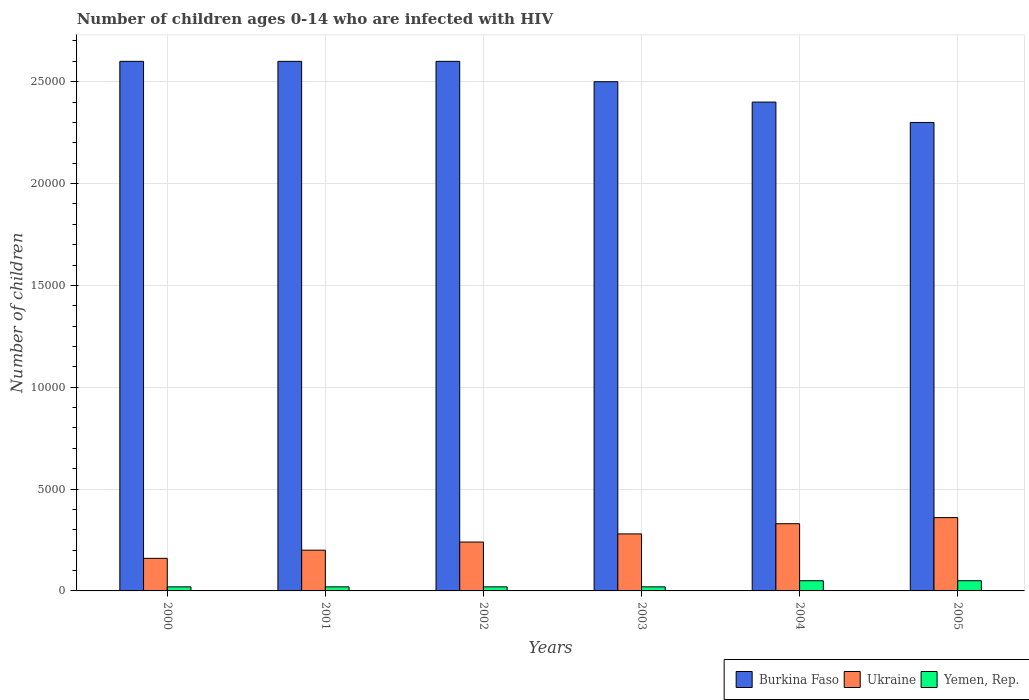How many different coloured bars are there?
Provide a succinct answer. 3. Are the number of bars per tick equal to the number of legend labels?
Provide a short and direct response. Yes. How many bars are there on the 3rd tick from the right?
Your answer should be very brief. 3. In how many cases, is the number of bars for a given year not equal to the number of legend labels?
Offer a very short reply. 0. What is the number of HIV infected children in Ukraine in 2002?
Your answer should be very brief. 2400. Across all years, what is the maximum number of HIV infected children in Yemen, Rep.?
Offer a very short reply. 500. Across all years, what is the minimum number of HIV infected children in Burkina Faso?
Give a very brief answer. 2.30e+04. In which year was the number of HIV infected children in Yemen, Rep. maximum?
Make the answer very short. 2004. In which year was the number of HIV infected children in Ukraine minimum?
Give a very brief answer. 2000. What is the total number of HIV infected children in Ukraine in the graph?
Provide a succinct answer. 1.57e+04. What is the difference between the number of HIV infected children in Yemen, Rep. in 2001 and the number of HIV infected children in Ukraine in 2004?
Give a very brief answer. -3100. What is the average number of HIV infected children in Ukraine per year?
Give a very brief answer. 2616.67. In the year 2002, what is the difference between the number of HIV infected children in Ukraine and number of HIV infected children in Burkina Faso?
Your answer should be very brief. -2.36e+04. What is the ratio of the number of HIV infected children in Ukraine in 2000 to that in 2005?
Make the answer very short. 0.44. What is the difference between the highest and the second highest number of HIV infected children in Yemen, Rep.?
Keep it short and to the point. 0. What is the difference between the highest and the lowest number of HIV infected children in Ukraine?
Ensure brevity in your answer.  2000. Is the sum of the number of HIV infected children in Yemen, Rep. in 2000 and 2004 greater than the maximum number of HIV infected children in Burkina Faso across all years?
Make the answer very short. No. What does the 2nd bar from the left in 2004 represents?
Offer a terse response. Ukraine. What does the 3rd bar from the right in 2000 represents?
Offer a terse response. Burkina Faso. How many bars are there?
Offer a very short reply. 18. How many years are there in the graph?
Provide a short and direct response. 6. Does the graph contain any zero values?
Provide a succinct answer. No. Does the graph contain grids?
Provide a succinct answer. Yes. Where does the legend appear in the graph?
Provide a succinct answer. Bottom right. What is the title of the graph?
Your answer should be very brief. Number of children ages 0-14 who are infected with HIV. Does "Caribbean small states" appear as one of the legend labels in the graph?
Offer a very short reply. No. What is the label or title of the X-axis?
Make the answer very short. Years. What is the label or title of the Y-axis?
Give a very brief answer. Number of children. What is the Number of children of Burkina Faso in 2000?
Your answer should be compact. 2.60e+04. What is the Number of children of Ukraine in 2000?
Give a very brief answer. 1600. What is the Number of children in Yemen, Rep. in 2000?
Provide a short and direct response. 200. What is the Number of children in Burkina Faso in 2001?
Give a very brief answer. 2.60e+04. What is the Number of children in Yemen, Rep. in 2001?
Your response must be concise. 200. What is the Number of children of Burkina Faso in 2002?
Make the answer very short. 2.60e+04. What is the Number of children in Ukraine in 2002?
Provide a succinct answer. 2400. What is the Number of children of Burkina Faso in 2003?
Ensure brevity in your answer.  2.50e+04. What is the Number of children of Ukraine in 2003?
Make the answer very short. 2800. What is the Number of children of Burkina Faso in 2004?
Provide a short and direct response. 2.40e+04. What is the Number of children of Ukraine in 2004?
Make the answer very short. 3300. What is the Number of children in Burkina Faso in 2005?
Your answer should be very brief. 2.30e+04. What is the Number of children of Ukraine in 2005?
Your answer should be compact. 3600. Across all years, what is the maximum Number of children of Burkina Faso?
Keep it short and to the point. 2.60e+04. Across all years, what is the maximum Number of children in Ukraine?
Give a very brief answer. 3600. Across all years, what is the maximum Number of children of Yemen, Rep.?
Make the answer very short. 500. Across all years, what is the minimum Number of children of Burkina Faso?
Your answer should be compact. 2.30e+04. Across all years, what is the minimum Number of children of Ukraine?
Your answer should be compact. 1600. Across all years, what is the minimum Number of children of Yemen, Rep.?
Provide a short and direct response. 200. What is the total Number of children in Burkina Faso in the graph?
Make the answer very short. 1.50e+05. What is the total Number of children of Ukraine in the graph?
Provide a short and direct response. 1.57e+04. What is the total Number of children of Yemen, Rep. in the graph?
Your answer should be very brief. 1800. What is the difference between the Number of children in Burkina Faso in 2000 and that in 2001?
Your response must be concise. 0. What is the difference between the Number of children of Ukraine in 2000 and that in 2001?
Provide a succinct answer. -400. What is the difference between the Number of children of Yemen, Rep. in 2000 and that in 2001?
Offer a terse response. 0. What is the difference between the Number of children in Ukraine in 2000 and that in 2002?
Provide a succinct answer. -800. What is the difference between the Number of children of Burkina Faso in 2000 and that in 2003?
Ensure brevity in your answer.  1000. What is the difference between the Number of children of Ukraine in 2000 and that in 2003?
Provide a short and direct response. -1200. What is the difference between the Number of children of Yemen, Rep. in 2000 and that in 2003?
Keep it short and to the point. 0. What is the difference between the Number of children in Burkina Faso in 2000 and that in 2004?
Ensure brevity in your answer.  2000. What is the difference between the Number of children in Ukraine in 2000 and that in 2004?
Ensure brevity in your answer.  -1700. What is the difference between the Number of children of Yemen, Rep. in 2000 and that in 2004?
Offer a terse response. -300. What is the difference between the Number of children in Burkina Faso in 2000 and that in 2005?
Make the answer very short. 3000. What is the difference between the Number of children in Ukraine in 2000 and that in 2005?
Keep it short and to the point. -2000. What is the difference between the Number of children of Yemen, Rep. in 2000 and that in 2005?
Offer a very short reply. -300. What is the difference between the Number of children in Ukraine in 2001 and that in 2002?
Offer a terse response. -400. What is the difference between the Number of children of Ukraine in 2001 and that in 2003?
Provide a short and direct response. -800. What is the difference between the Number of children of Yemen, Rep. in 2001 and that in 2003?
Offer a very short reply. 0. What is the difference between the Number of children in Ukraine in 2001 and that in 2004?
Keep it short and to the point. -1300. What is the difference between the Number of children of Yemen, Rep. in 2001 and that in 2004?
Your response must be concise. -300. What is the difference between the Number of children of Burkina Faso in 2001 and that in 2005?
Give a very brief answer. 3000. What is the difference between the Number of children of Ukraine in 2001 and that in 2005?
Your answer should be compact. -1600. What is the difference between the Number of children of Yemen, Rep. in 2001 and that in 2005?
Keep it short and to the point. -300. What is the difference between the Number of children of Ukraine in 2002 and that in 2003?
Provide a short and direct response. -400. What is the difference between the Number of children of Yemen, Rep. in 2002 and that in 2003?
Provide a succinct answer. 0. What is the difference between the Number of children in Ukraine in 2002 and that in 2004?
Ensure brevity in your answer.  -900. What is the difference between the Number of children in Yemen, Rep. in 2002 and that in 2004?
Your response must be concise. -300. What is the difference between the Number of children of Burkina Faso in 2002 and that in 2005?
Give a very brief answer. 3000. What is the difference between the Number of children in Ukraine in 2002 and that in 2005?
Keep it short and to the point. -1200. What is the difference between the Number of children in Yemen, Rep. in 2002 and that in 2005?
Ensure brevity in your answer.  -300. What is the difference between the Number of children in Burkina Faso in 2003 and that in 2004?
Provide a succinct answer. 1000. What is the difference between the Number of children in Ukraine in 2003 and that in 2004?
Provide a succinct answer. -500. What is the difference between the Number of children in Yemen, Rep. in 2003 and that in 2004?
Your answer should be compact. -300. What is the difference between the Number of children of Burkina Faso in 2003 and that in 2005?
Make the answer very short. 2000. What is the difference between the Number of children in Ukraine in 2003 and that in 2005?
Offer a very short reply. -800. What is the difference between the Number of children of Yemen, Rep. in 2003 and that in 2005?
Give a very brief answer. -300. What is the difference between the Number of children in Burkina Faso in 2004 and that in 2005?
Keep it short and to the point. 1000. What is the difference between the Number of children of Ukraine in 2004 and that in 2005?
Offer a very short reply. -300. What is the difference between the Number of children in Burkina Faso in 2000 and the Number of children in Ukraine in 2001?
Provide a succinct answer. 2.40e+04. What is the difference between the Number of children of Burkina Faso in 2000 and the Number of children of Yemen, Rep. in 2001?
Offer a very short reply. 2.58e+04. What is the difference between the Number of children of Ukraine in 2000 and the Number of children of Yemen, Rep. in 2001?
Your response must be concise. 1400. What is the difference between the Number of children of Burkina Faso in 2000 and the Number of children of Ukraine in 2002?
Give a very brief answer. 2.36e+04. What is the difference between the Number of children of Burkina Faso in 2000 and the Number of children of Yemen, Rep. in 2002?
Make the answer very short. 2.58e+04. What is the difference between the Number of children of Ukraine in 2000 and the Number of children of Yemen, Rep. in 2002?
Your response must be concise. 1400. What is the difference between the Number of children of Burkina Faso in 2000 and the Number of children of Ukraine in 2003?
Your answer should be very brief. 2.32e+04. What is the difference between the Number of children of Burkina Faso in 2000 and the Number of children of Yemen, Rep. in 2003?
Offer a terse response. 2.58e+04. What is the difference between the Number of children in Ukraine in 2000 and the Number of children in Yemen, Rep. in 2003?
Offer a very short reply. 1400. What is the difference between the Number of children in Burkina Faso in 2000 and the Number of children in Ukraine in 2004?
Provide a short and direct response. 2.27e+04. What is the difference between the Number of children of Burkina Faso in 2000 and the Number of children of Yemen, Rep. in 2004?
Offer a terse response. 2.55e+04. What is the difference between the Number of children in Ukraine in 2000 and the Number of children in Yemen, Rep. in 2004?
Offer a terse response. 1100. What is the difference between the Number of children of Burkina Faso in 2000 and the Number of children of Ukraine in 2005?
Offer a very short reply. 2.24e+04. What is the difference between the Number of children of Burkina Faso in 2000 and the Number of children of Yemen, Rep. in 2005?
Your response must be concise. 2.55e+04. What is the difference between the Number of children in Ukraine in 2000 and the Number of children in Yemen, Rep. in 2005?
Keep it short and to the point. 1100. What is the difference between the Number of children in Burkina Faso in 2001 and the Number of children in Ukraine in 2002?
Keep it short and to the point. 2.36e+04. What is the difference between the Number of children in Burkina Faso in 2001 and the Number of children in Yemen, Rep. in 2002?
Keep it short and to the point. 2.58e+04. What is the difference between the Number of children of Ukraine in 2001 and the Number of children of Yemen, Rep. in 2002?
Ensure brevity in your answer.  1800. What is the difference between the Number of children in Burkina Faso in 2001 and the Number of children in Ukraine in 2003?
Keep it short and to the point. 2.32e+04. What is the difference between the Number of children of Burkina Faso in 2001 and the Number of children of Yemen, Rep. in 2003?
Provide a succinct answer. 2.58e+04. What is the difference between the Number of children in Ukraine in 2001 and the Number of children in Yemen, Rep. in 2003?
Your response must be concise. 1800. What is the difference between the Number of children of Burkina Faso in 2001 and the Number of children of Ukraine in 2004?
Your answer should be very brief. 2.27e+04. What is the difference between the Number of children in Burkina Faso in 2001 and the Number of children in Yemen, Rep. in 2004?
Make the answer very short. 2.55e+04. What is the difference between the Number of children of Ukraine in 2001 and the Number of children of Yemen, Rep. in 2004?
Offer a very short reply. 1500. What is the difference between the Number of children of Burkina Faso in 2001 and the Number of children of Ukraine in 2005?
Keep it short and to the point. 2.24e+04. What is the difference between the Number of children in Burkina Faso in 2001 and the Number of children in Yemen, Rep. in 2005?
Provide a succinct answer. 2.55e+04. What is the difference between the Number of children in Ukraine in 2001 and the Number of children in Yemen, Rep. in 2005?
Make the answer very short. 1500. What is the difference between the Number of children in Burkina Faso in 2002 and the Number of children in Ukraine in 2003?
Your answer should be compact. 2.32e+04. What is the difference between the Number of children in Burkina Faso in 2002 and the Number of children in Yemen, Rep. in 2003?
Give a very brief answer. 2.58e+04. What is the difference between the Number of children in Ukraine in 2002 and the Number of children in Yemen, Rep. in 2003?
Provide a short and direct response. 2200. What is the difference between the Number of children in Burkina Faso in 2002 and the Number of children in Ukraine in 2004?
Provide a succinct answer. 2.27e+04. What is the difference between the Number of children in Burkina Faso in 2002 and the Number of children in Yemen, Rep. in 2004?
Ensure brevity in your answer.  2.55e+04. What is the difference between the Number of children in Ukraine in 2002 and the Number of children in Yemen, Rep. in 2004?
Your response must be concise. 1900. What is the difference between the Number of children in Burkina Faso in 2002 and the Number of children in Ukraine in 2005?
Provide a short and direct response. 2.24e+04. What is the difference between the Number of children in Burkina Faso in 2002 and the Number of children in Yemen, Rep. in 2005?
Provide a short and direct response. 2.55e+04. What is the difference between the Number of children of Ukraine in 2002 and the Number of children of Yemen, Rep. in 2005?
Make the answer very short. 1900. What is the difference between the Number of children of Burkina Faso in 2003 and the Number of children of Ukraine in 2004?
Your answer should be compact. 2.17e+04. What is the difference between the Number of children of Burkina Faso in 2003 and the Number of children of Yemen, Rep. in 2004?
Make the answer very short. 2.45e+04. What is the difference between the Number of children of Ukraine in 2003 and the Number of children of Yemen, Rep. in 2004?
Your response must be concise. 2300. What is the difference between the Number of children of Burkina Faso in 2003 and the Number of children of Ukraine in 2005?
Provide a short and direct response. 2.14e+04. What is the difference between the Number of children in Burkina Faso in 2003 and the Number of children in Yemen, Rep. in 2005?
Give a very brief answer. 2.45e+04. What is the difference between the Number of children in Ukraine in 2003 and the Number of children in Yemen, Rep. in 2005?
Ensure brevity in your answer.  2300. What is the difference between the Number of children in Burkina Faso in 2004 and the Number of children in Ukraine in 2005?
Your answer should be very brief. 2.04e+04. What is the difference between the Number of children of Burkina Faso in 2004 and the Number of children of Yemen, Rep. in 2005?
Give a very brief answer. 2.35e+04. What is the difference between the Number of children in Ukraine in 2004 and the Number of children in Yemen, Rep. in 2005?
Ensure brevity in your answer.  2800. What is the average Number of children of Burkina Faso per year?
Provide a succinct answer. 2.50e+04. What is the average Number of children in Ukraine per year?
Your response must be concise. 2616.67. What is the average Number of children of Yemen, Rep. per year?
Your answer should be compact. 300. In the year 2000, what is the difference between the Number of children in Burkina Faso and Number of children in Ukraine?
Make the answer very short. 2.44e+04. In the year 2000, what is the difference between the Number of children in Burkina Faso and Number of children in Yemen, Rep.?
Your response must be concise. 2.58e+04. In the year 2000, what is the difference between the Number of children of Ukraine and Number of children of Yemen, Rep.?
Offer a terse response. 1400. In the year 2001, what is the difference between the Number of children of Burkina Faso and Number of children of Ukraine?
Make the answer very short. 2.40e+04. In the year 2001, what is the difference between the Number of children of Burkina Faso and Number of children of Yemen, Rep.?
Offer a terse response. 2.58e+04. In the year 2001, what is the difference between the Number of children of Ukraine and Number of children of Yemen, Rep.?
Make the answer very short. 1800. In the year 2002, what is the difference between the Number of children of Burkina Faso and Number of children of Ukraine?
Your response must be concise. 2.36e+04. In the year 2002, what is the difference between the Number of children in Burkina Faso and Number of children in Yemen, Rep.?
Your answer should be compact. 2.58e+04. In the year 2002, what is the difference between the Number of children of Ukraine and Number of children of Yemen, Rep.?
Ensure brevity in your answer.  2200. In the year 2003, what is the difference between the Number of children of Burkina Faso and Number of children of Ukraine?
Provide a short and direct response. 2.22e+04. In the year 2003, what is the difference between the Number of children in Burkina Faso and Number of children in Yemen, Rep.?
Provide a succinct answer. 2.48e+04. In the year 2003, what is the difference between the Number of children of Ukraine and Number of children of Yemen, Rep.?
Offer a terse response. 2600. In the year 2004, what is the difference between the Number of children of Burkina Faso and Number of children of Ukraine?
Make the answer very short. 2.07e+04. In the year 2004, what is the difference between the Number of children of Burkina Faso and Number of children of Yemen, Rep.?
Ensure brevity in your answer.  2.35e+04. In the year 2004, what is the difference between the Number of children of Ukraine and Number of children of Yemen, Rep.?
Your response must be concise. 2800. In the year 2005, what is the difference between the Number of children of Burkina Faso and Number of children of Ukraine?
Your answer should be very brief. 1.94e+04. In the year 2005, what is the difference between the Number of children of Burkina Faso and Number of children of Yemen, Rep.?
Give a very brief answer. 2.25e+04. In the year 2005, what is the difference between the Number of children of Ukraine and Number of children of Yemen, Rep.?
Provide a succinct answer. 3100. What is the ratio of the Number of children of Burkina Faso in 2000 to that in 2001?
Provide a succinct answer. 1. What is the ratio of the Number of children in Ukraine in 2000 to that in 2001?
Ensure brevity in your answer.  0.8. What is the ratio of the Number of children in Burkina Faso in 2000 to that in 2002?
Your answer should be very brief. 1. What is the ratio of the Number of children in Ukraine in 2000 to that in 2002?
Your response must be concise. 0.67. What is the ratio of the Number of children in Burkina Faso in 2000 to that in 2003?
Your answer should be compact. 1.04. What is the ratio of the Number of children in Ukraine in 2000 to that in 2004?
Your response must be concise. 0.48. What is the ratio of the Number of children of Yemen, Rep. in 2000 to that in 2004?
Give a very brief answer. 0.4. What is the ratio of the Number of children in Burkina Faso in 2000 to that in 2005?
Your answer should be compact. 1.13. What is the ratio of the Number of children in Ukraine in 2000 to that in 2005?
Your response must be concise. 0.44. What is the ratio of the Number of children of Yemen, Rep. in 2000 to that in 2005?
Offer a terse response. 0.4. What is the ratio of the Number of children of Burkina Faso in 2001 to that in 2003?
Keep it short and to the point. 1.04. What is the ratio of the Number of children in Yemen, Rep. in 2001 to that in 2003?
Offer a terse response. 1. What is the ratio of the Number of children of Burkina Faso in 2001 to that in 2004?
Make the answer very short. 1.08. What is the ratio of the Number of children in Ukraine in 2001 to that in 2004?
Provide a succinct answer. 0.61. What is the ratio of the Number of children of Yemen, Rep. in 2001 to that in 2004?
Ensure brevity in your answer.  0.4. What is the ratio of the Number of children in Burkina Faso in 2001 to that in 2005?
Keep it short and to the point. 1.13. What is the ratio of the Number of children in Ukraine in 2001 to that in 2005?
Your answer should be very brief. 0.56. What is the ratio of the Number of children in Ukraine in 2002 to that in 2003?
Offer a very short reply. 0.86. What is the ratio of the Number of children of Yemen, Rep. in 2002 to that in 2003?
Offer a very short reply. 1. What is the ratio of the Number of children in Burkina Faso in 2002 to that in 2004?
Provide a succinct answer. 1.08. What is the ratio of the Number of children of Ukraine in 2002 to that in 2004?
Ensure brevity in your answer.  0.73. What is the ratio of the Number of children in Burkina Faso in 2002 to that in 2005?
Your answer should be compact. 1.13. What is the ratio of the Number of children in Ukraine in 2002 to that in 2005?
Offer a terse response. 0.67. What is the ratio of the Number of children in Burkina Faso in 2003 to that in 2004?
Offer a terse response. 1.04. What is the ratio of the Number of children in Ukraine in 2003 to that in 2004?
Make the answer very short. 0.85. What is the ratio of the Number of children in Burkina Faso in 2003 to that in 2005?
Give a very brief answer. 1.09. What is the ratio of the Number of children in Burkina Faso in 2004 to that in 2005?
Provide a succinct answer. 1.04. What is the ratio of the Number of children in Yemen, Rep. in 2004 to that in 2005?
Make the answer very short. 1. What is the difference between the highest and the second highest Number of children of Ukraine?
Offer a terse response. 300. What is the difference between the highest and the second highest Number of children of Yemen, Rep.?
Keep it short and to the point. 0. What is the difference between the highest and the lowest Number of children of Burkina Faso?
Provide a short and direct response. 3000. What is the difference between the highest and the lowest Number of children in Yemen, Rep.?
Provide a succinct answer. 300. 